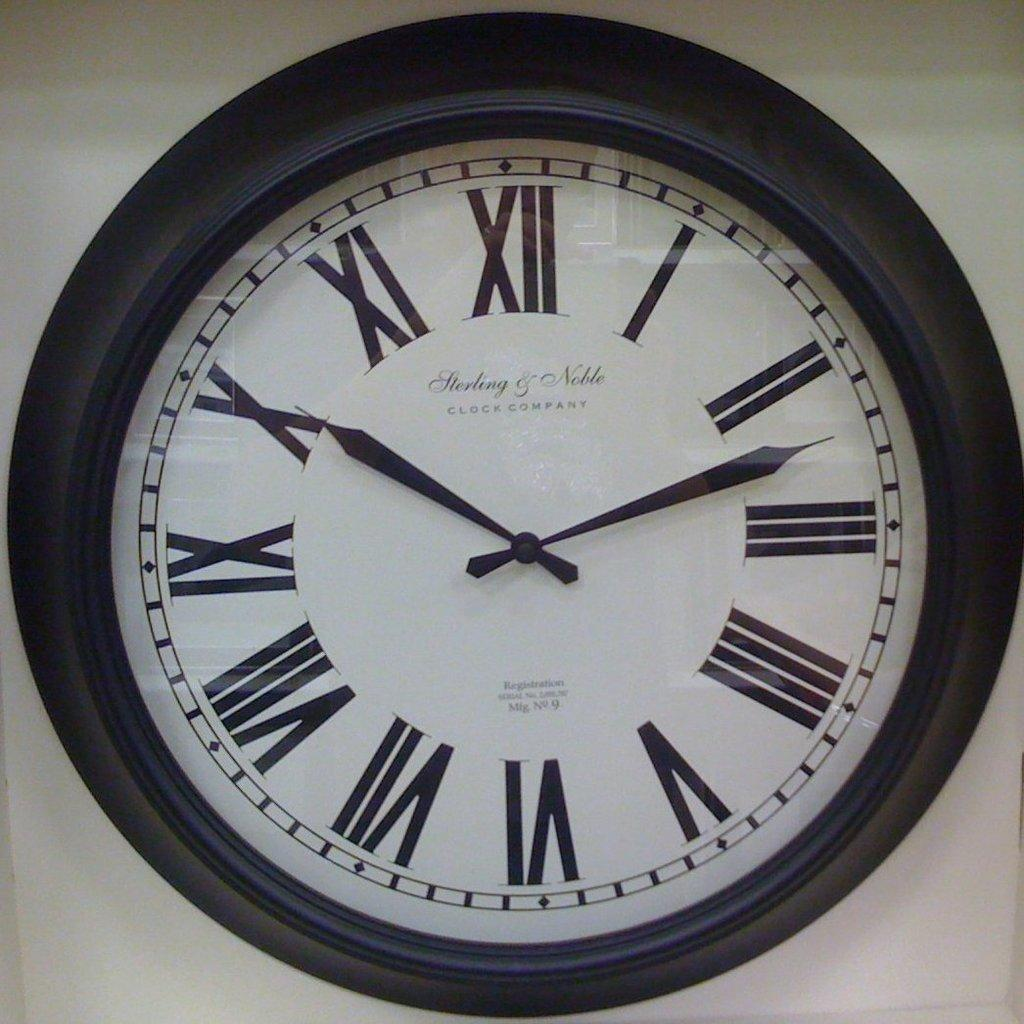<image>
Create a compact narrative representing the image presented. An analog wall clock made by the Sterling & Noble Clock Company. 